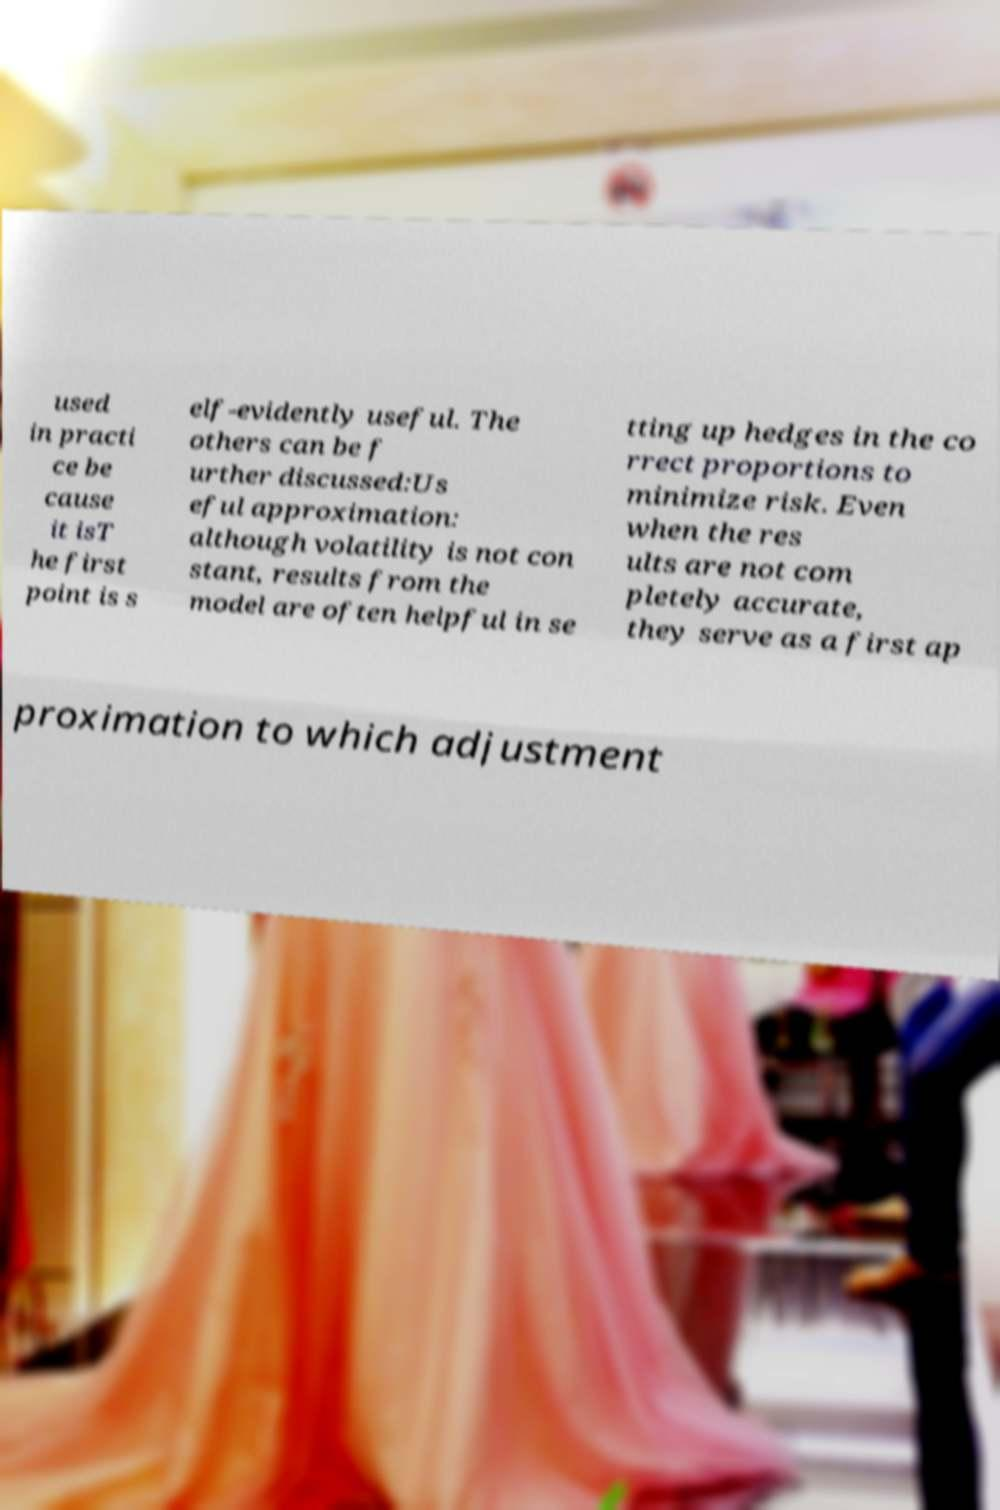Could you assist in decoding the text presented in this image and type it out clearly? used in practi ce be cause it isT he first point is s elf-evidently useful. The others can be f urther discussed:Us eful approximation: although volatility is not con stant, results from the model are often helpful in se tting up hedges in the co rrect proportions to minimize risk. Even when the res ults are not com pletely accurate, they serve as a first ap proximation to which adjustment 